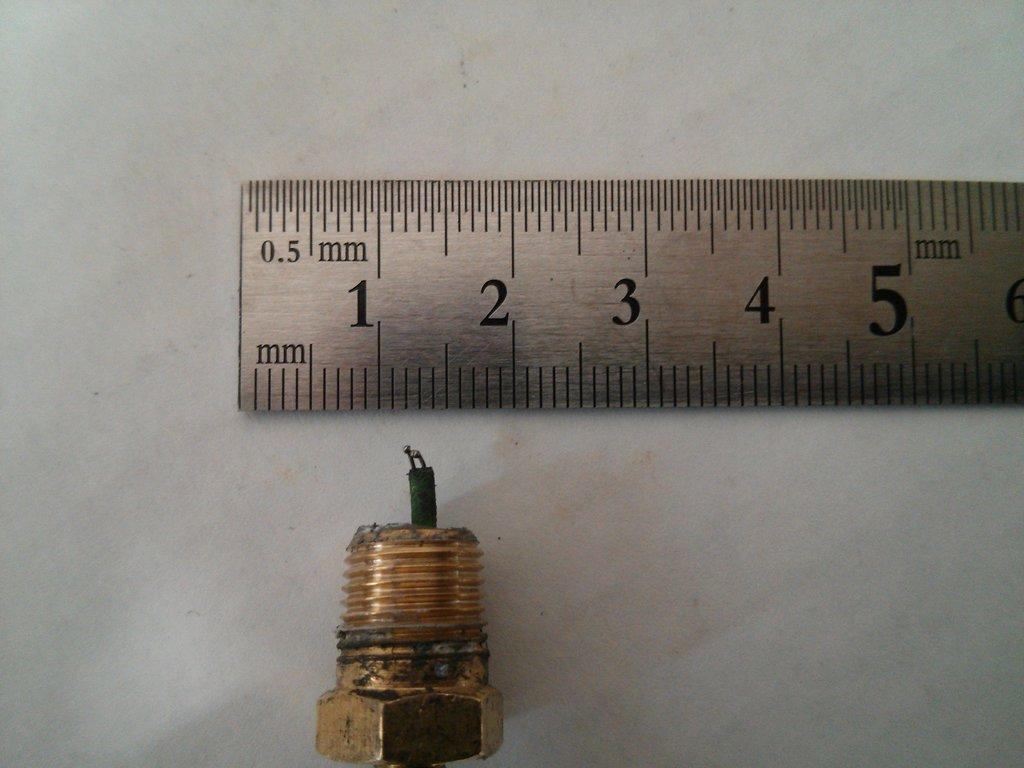<image>
Offer a succinct explanation of the picture presented. Threaded bolt in gold next to a millimeter ruler. 